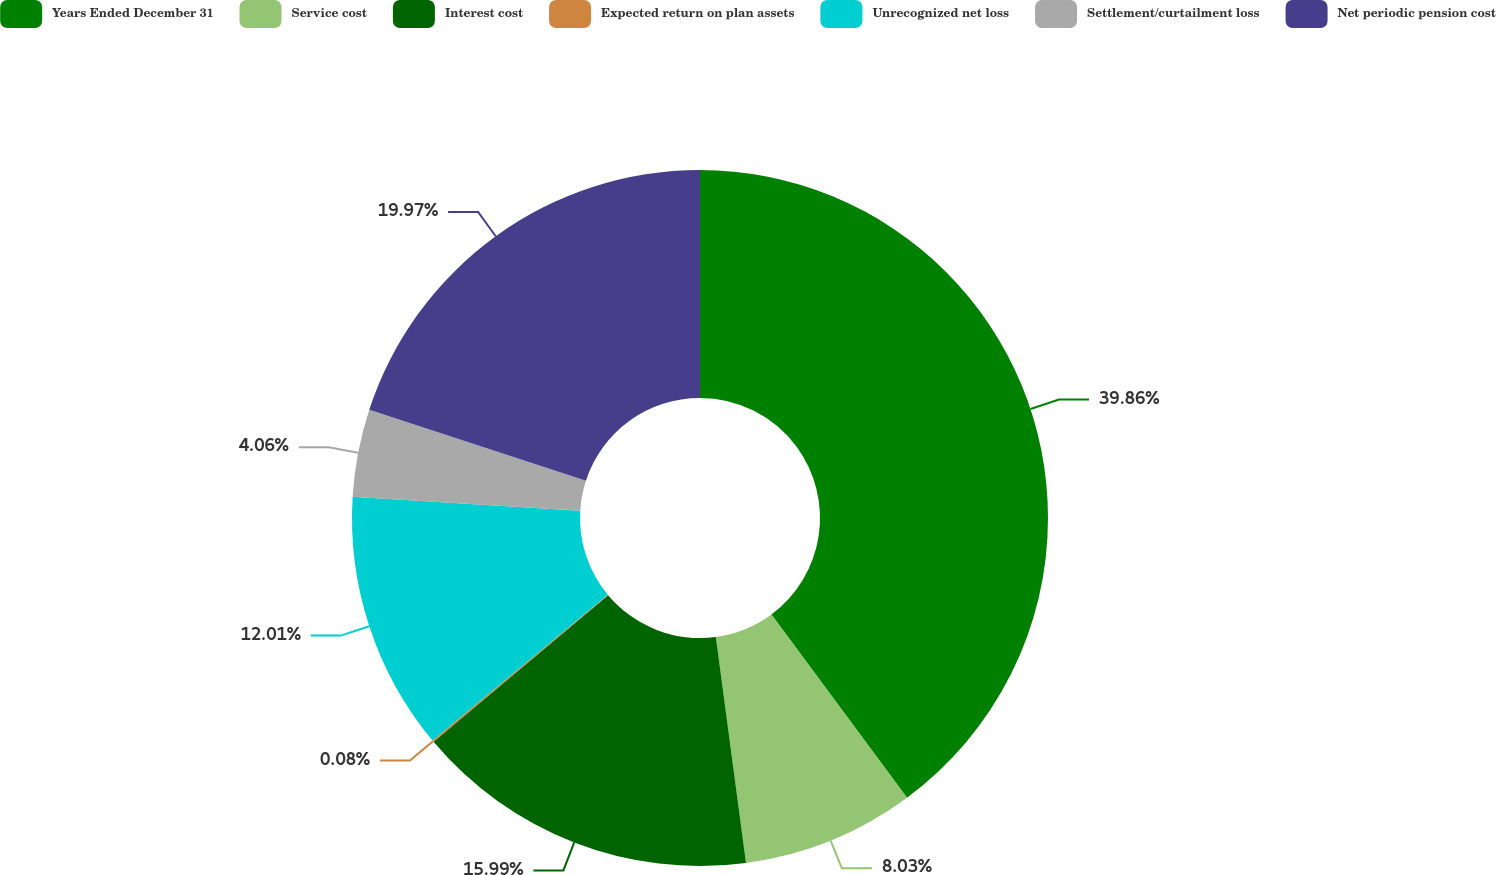Convert chart. <chart><loc_0><loc_0><loc_500><loc_500><pie_chart><fcel>Years Ended December 31<fcel>Service cost<fcel>Interest cost<fcel>Expected return on plan assets<fcel>Unrecognized net loss<fcel>Settlement/curtailment loss<fcel>Net periodic pension cost<nl><fcel>39.86%<fcel>8.03%<fcel>15.99%<fcel>0.08%<fcel>12.01%<fcel>4.06%<fcel>19.97%<nl></chart> 